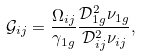<formula> <loc_0><loc_0><loc_500><loc_500>\mathcal { G } _ { i j } = \frac { \Omega _ { i j } } { \gamma _ { 1 g } } \frac { \mathcal { D } _ { 1 g } ^ { 2 } \nu _ { 1 g } } { \mathcal { D } _ { i j } ^ { 2 } \nu _ { i j } } ,</formula> 